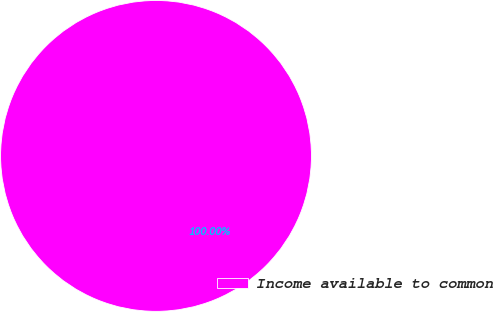Convert chart. <chart><loc_0><loc_0><loc_500><loc_500><pie_chart><fcel>Income available to common<nl><fcel>100.0%<nl></chart> 